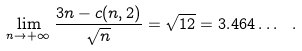<formula> <loc_0><loc_0><loc_500><loc_500>\lim _ { n \to + \infty } \frac { 3 n - c ( n , 2 ) } { \sqrt { n } } = \sqrt { 1 2 } = 3 . 4 6 4 \dots \ .</formula> 